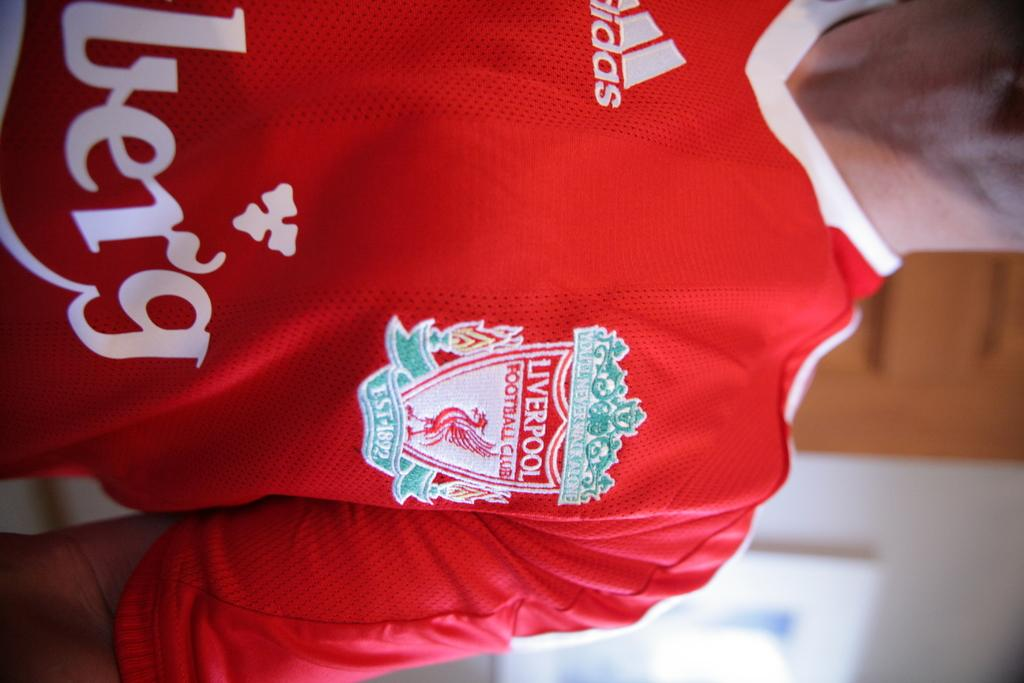<image>
Provide a brief description of the given image. LIVERPOOL is found on the red shirt of the player facing frontwards. 